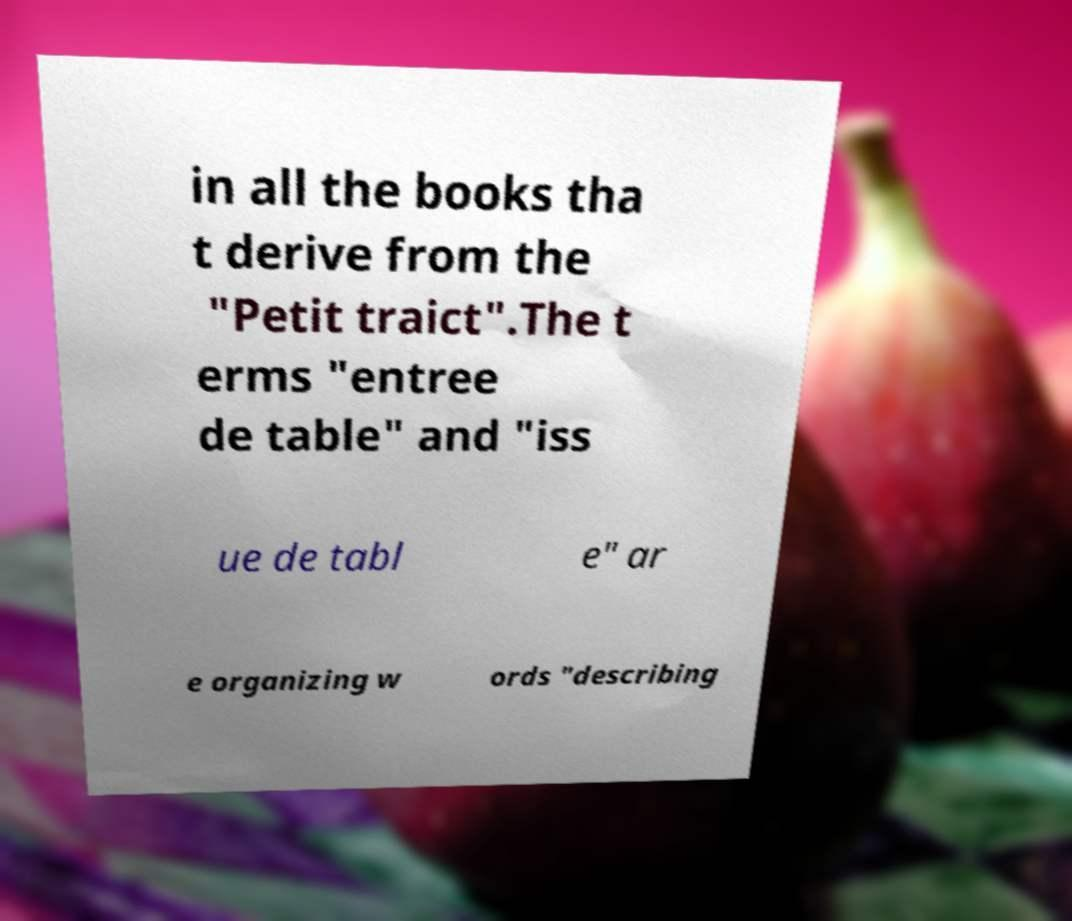Could you extract and type out the text from this image? in all the books tha t derive from the "Petit traict".The t erms "entree de table" and "iss ue de tabl e" ar e organizing w ords "describing 